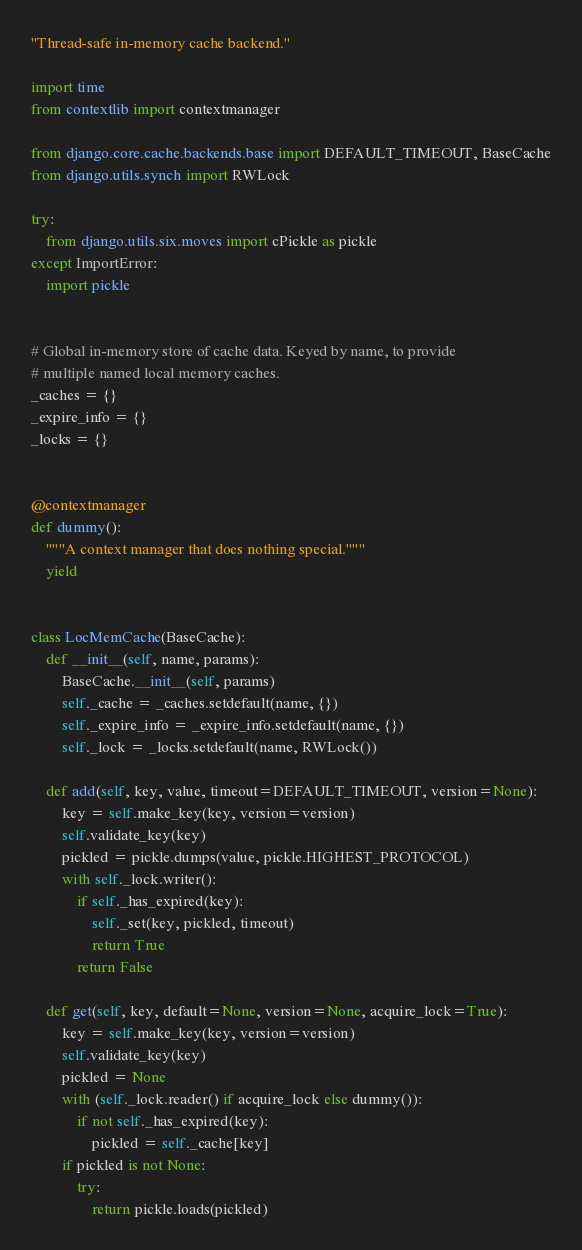<code> <loc_0><loc_0><loc_500><loc_500><_Python_>"Thread-safe in-memory cache backend."

import time
from contextlib import contextmanager

from django.core.cache.backends.base import DEFAULT_TIMEOUT, BaseCache
from django.utils.synch import RWLock

try:
    from django.utils.six.moves import cPickle as pickle
except ImportError:
    import pickle


# Global in-memory store of cache data. Keyed by name, to provide
# multiple named local memory caches.
_caches = {}
_expire_info = {}
_locks = {}


@contextmanager
def dummy():
    """A context manager that does nothing special."""
    yield


class LocMemCache(BaseCache):
    def __init__(self, name, params):
        BaseCache.__init__(self, params)
        self._cache = _caches.setdefault(name, {})
        self._expire_info = _expire_info.setdefault(name, {})
        self._lock = _locks.setdefault(name, RWLock())

    def add(self, key, value, timeout=DEFAULT_TIMEOUT, version=None):
        key = self.make_key(key, version=version)
        self.validate_key(key)
        pickled = pickle.dumps(value, pickle.HIGHEST_PROTOCOL)
        with self._lock.writer():
            if self._has_expired(key):
                self._set(key, pickled, timeout)
                return True
            return False

    def get(self, key, default=None, version=None, acquire_lock=True):
        key = self.make_key(key, version=version)
        self.validate_key(key)
        pickled = None
        with (self._lock.reader() if acquire_lock else dummy()):
            if not self._has_expired(key):
                pickled = self._cache[key]
        if pickled is not None:
            try:
                return pickle.loads(pickled)</code> 